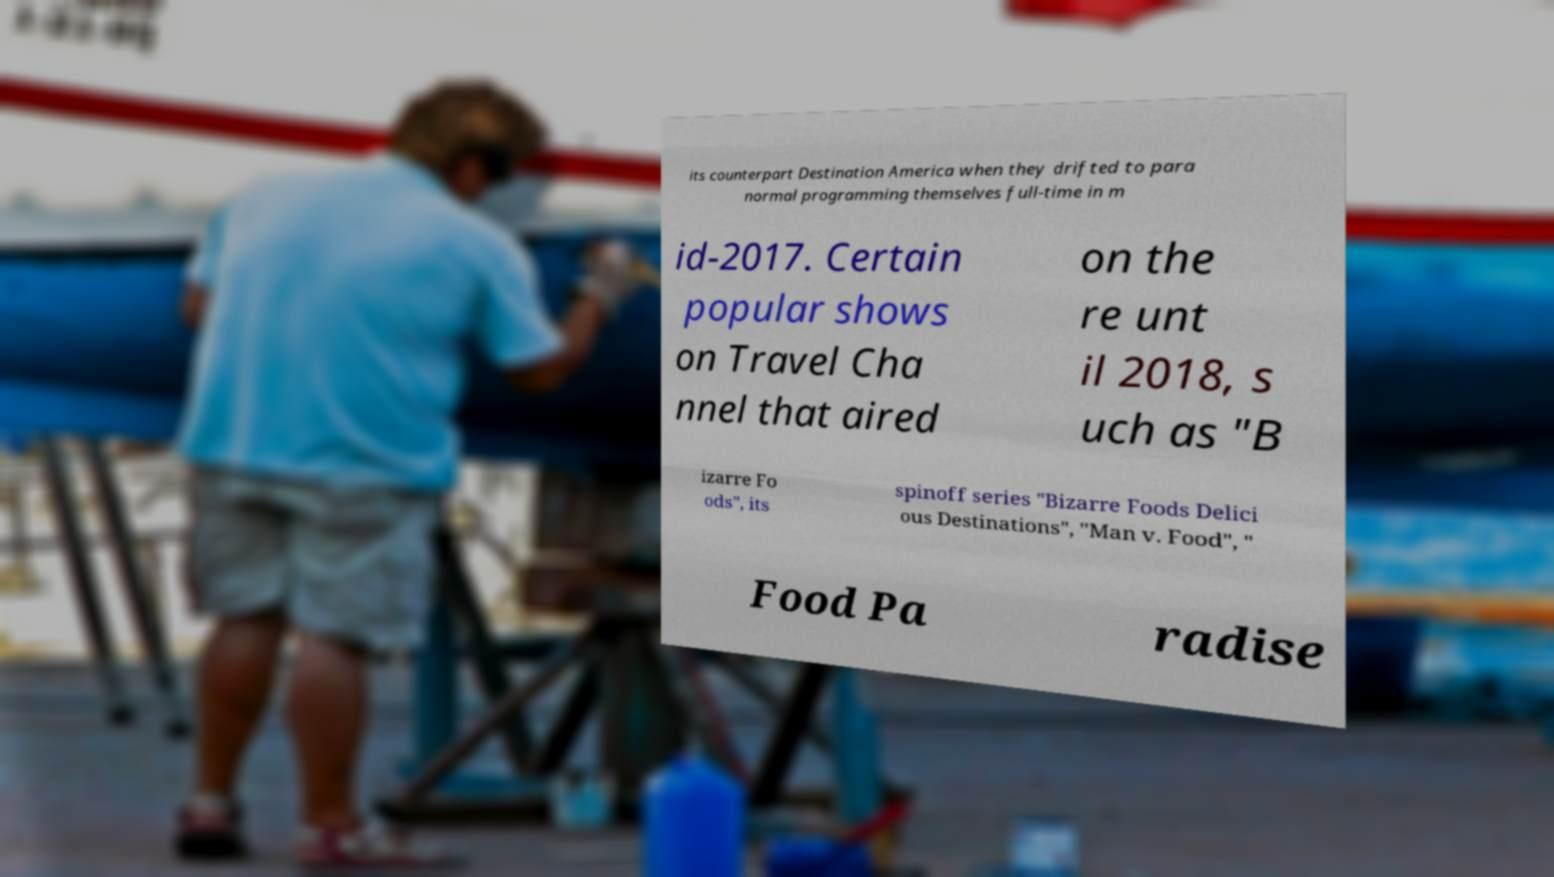Please read and relay the text visible in this image. What does it say? its counterpart Destination America when they drifted to para normal programming themselves full-time in m id-2017. Certain popular shows on Travel Cha nnel that aired on the re unt il 2018, s uch as "B izarre Fo ods", its spinoff series "Bizarre Foods Delici ous Destinations", "Man v. Food", " Food Pa radise 